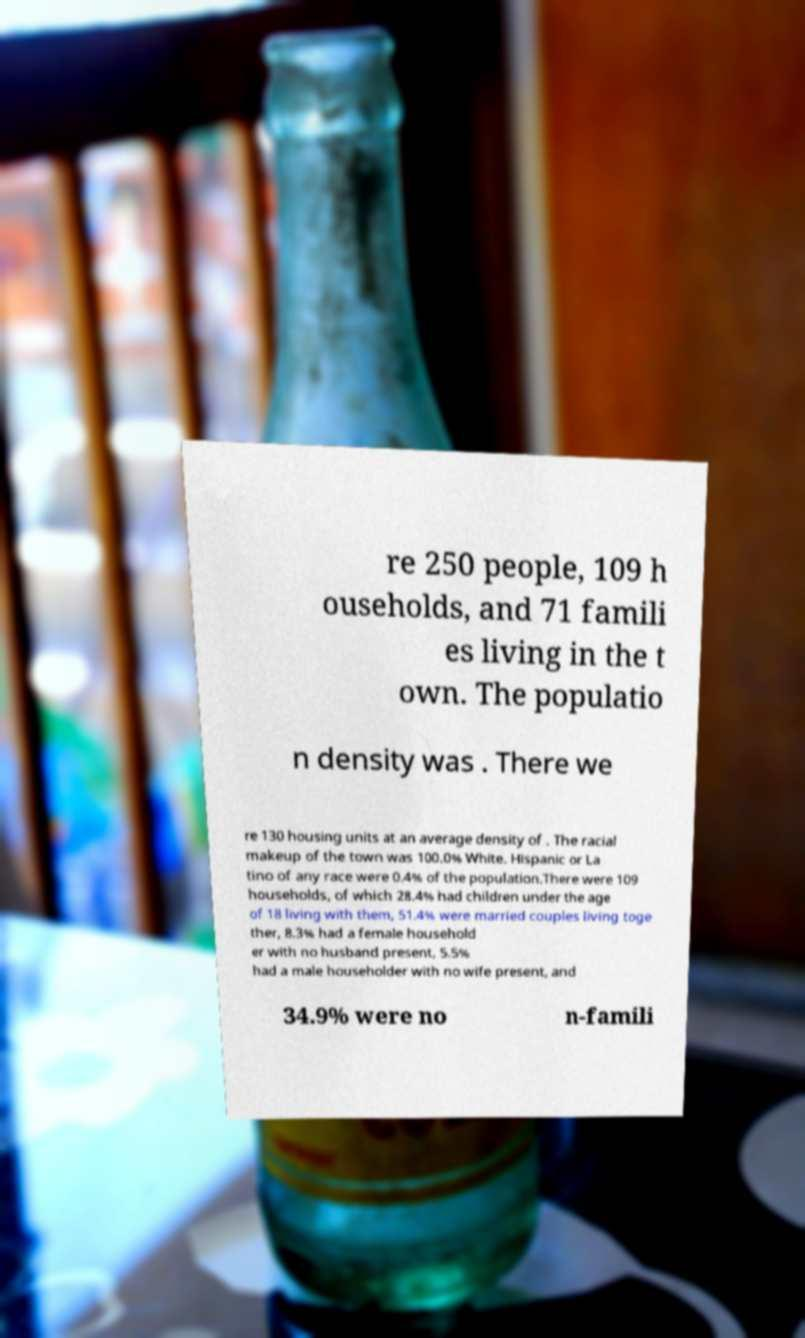Can you accurately transcribe the text from the provided image for me? re 250 people, 109 h ouseholds, and 71 famili es living in the t own. The populatio n density was . There we re 130 housing units at an average density of . The racial makeup of the town was 100.0% White. Hispanic or La tino of any race were 0.4% of the population.There were 109 households, of which 28.4% had children under the age of 18 living with them, 51.4% were married couples living toge ther, 8.3% had a female household er with no husband present, 5.5% had a male householder with no wife present, and 34.9% were no n-famili 